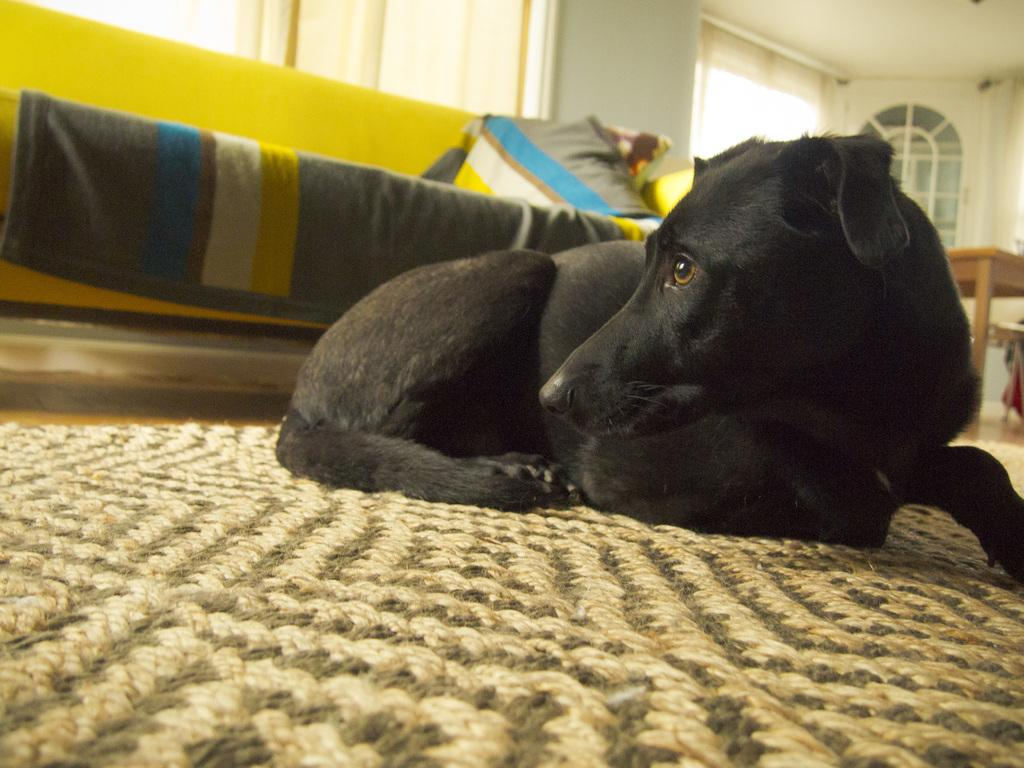What type of animal is in the image? There is a black dog in the image. What is the dog doing in the image? The dog is laying on a mat floor. What furniture is visible behind the dog? There is a sofa behind the dog. What other piece of furniture is present in the image? There is a table on the right side of the image. What architectural features can be seen in the background of the image? There is a door and a window on the wall in the background of the image. What type of legal advice is the dog offering in the image? There is no indication in the image that the dog is offering legal advice or any type of advice. 